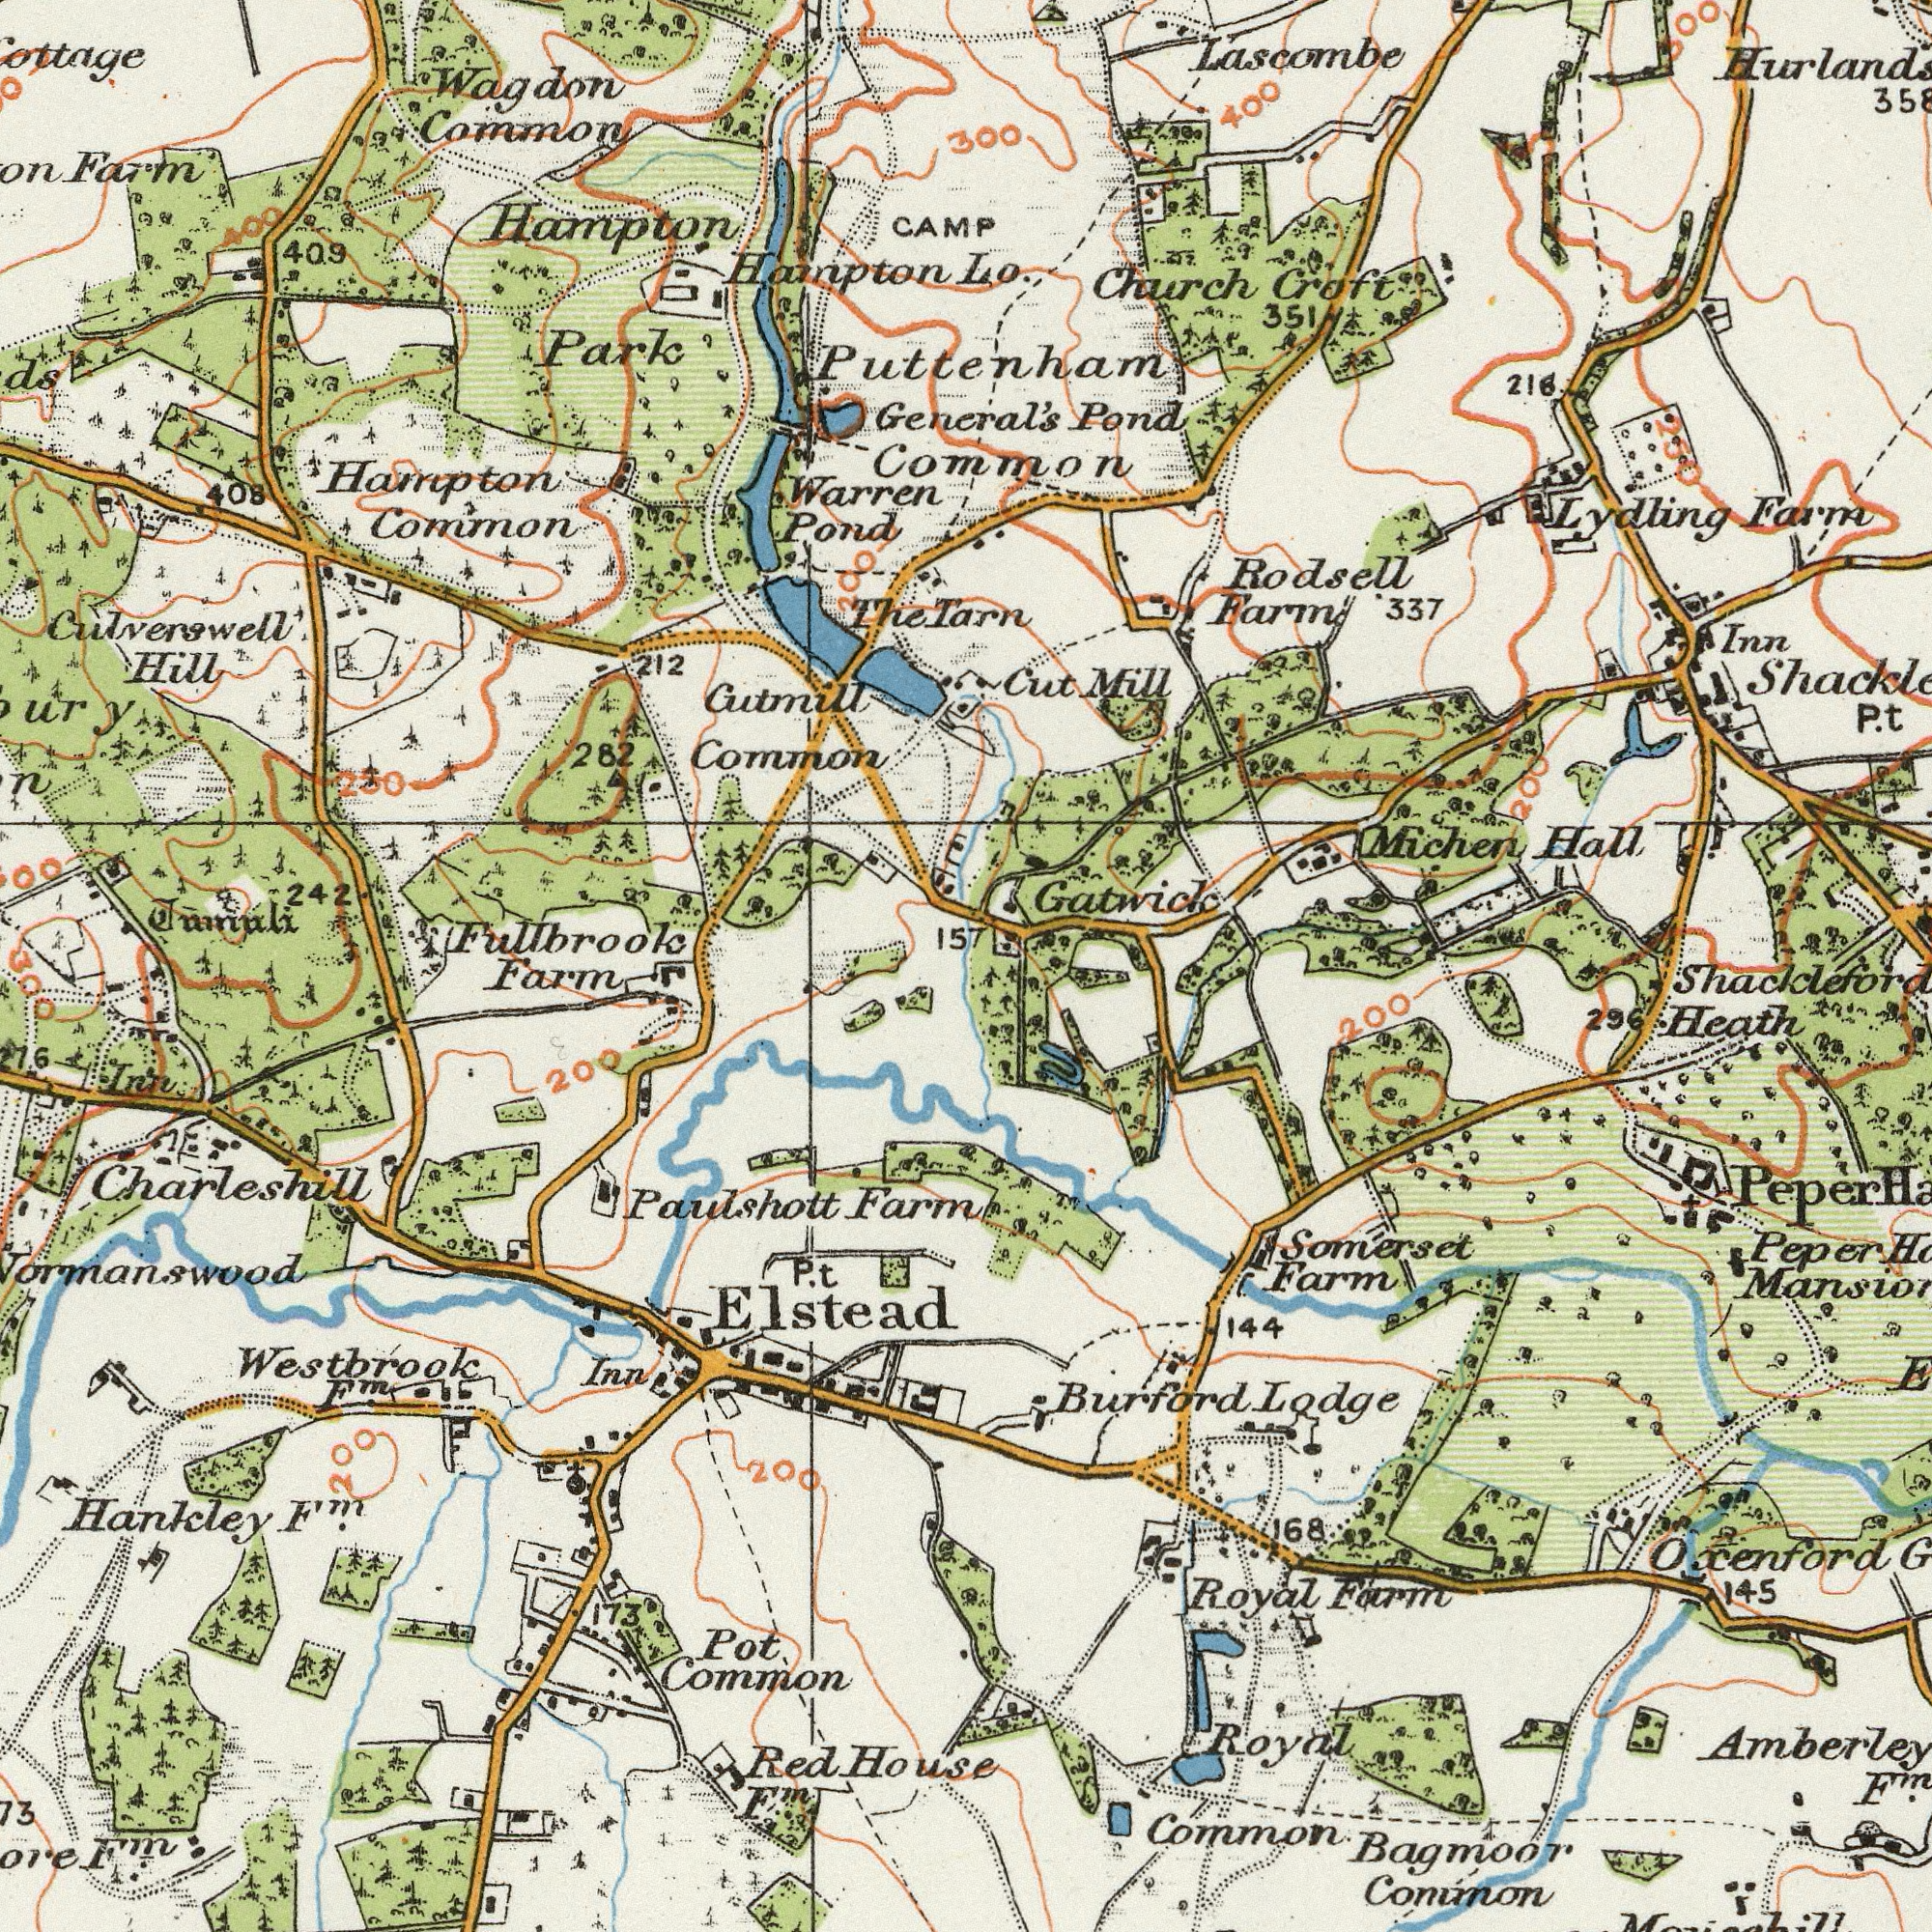What text is visible in the upper-right corner? Gatwick Lascombe Rodsell Michen Croft Farm Mill Lydling Pond Cut Lo. Farm 216 Hall Common Inn 337 Church P. Puttenham Tarn 351 300 400 300 General's t 200 250 What text appears in the top-left area of the image? Hampton Common Warren Pond Hampton Park Common 212 Cutmill Farm Hill 282 The CAMP Hampton 408 242 Culverswell Common Wagdon 157 Fullbrook 409 Jumuli 250 200 400 What text can you see in the bottom-right section? Bagmoor Common Common Burford Royal Heath Royal Peper Amberley Farm 168 Farm 145 296 144 Somerset Peper Lodge Oxenford F<sup>m</sup>. Shackleford 200 What text appears in the bottom-left area of the image? Hankley Common Pot House P. Farm Inn Red Farm Paulshott Westbrook Charleshill Inn 173 200 Elstead F<sup>m</sup>. F<sup>m</sup>. 200 300 t 200 F<sup>m</sup>. F<sup>m</sup>. 